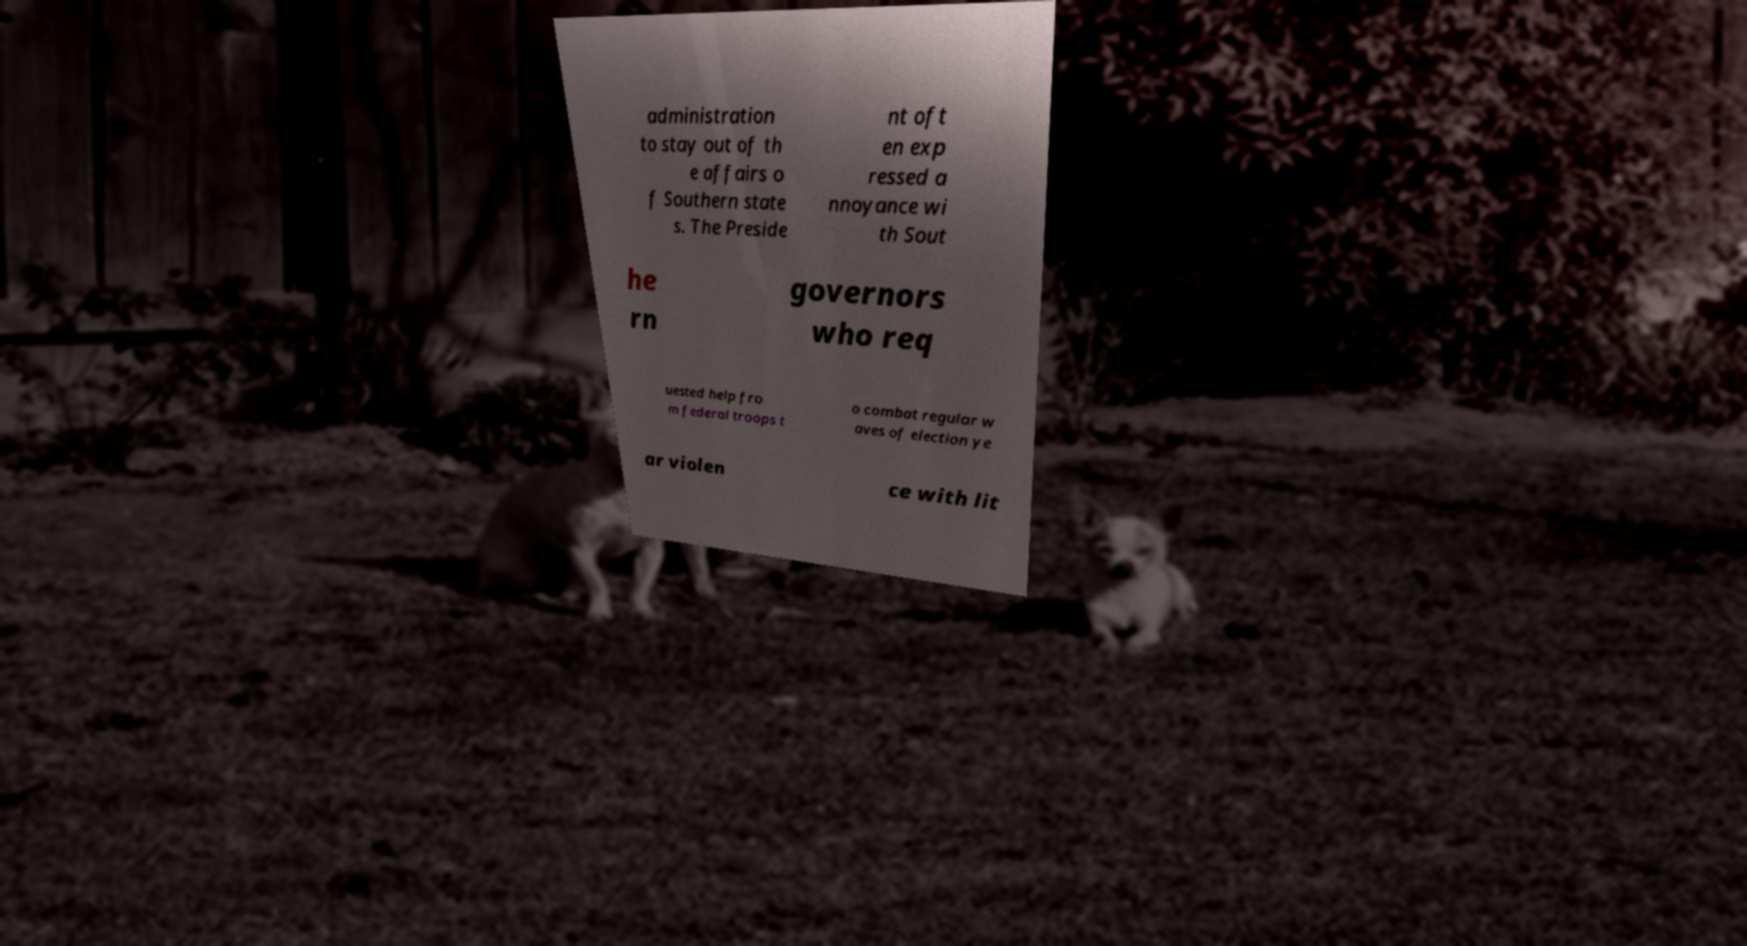Can you read and provide the text displayed in the image?This photo seems to have some interesting text. Can you extract and type it out for me? administration to stay out of th e affairs o f Southern state s. The Preside nt oft en exp ressed a nnoyance wi th Sout he rn governors who req uested help fro m federal troops t o combat regular w aves of election ye ar violen ce with lit 